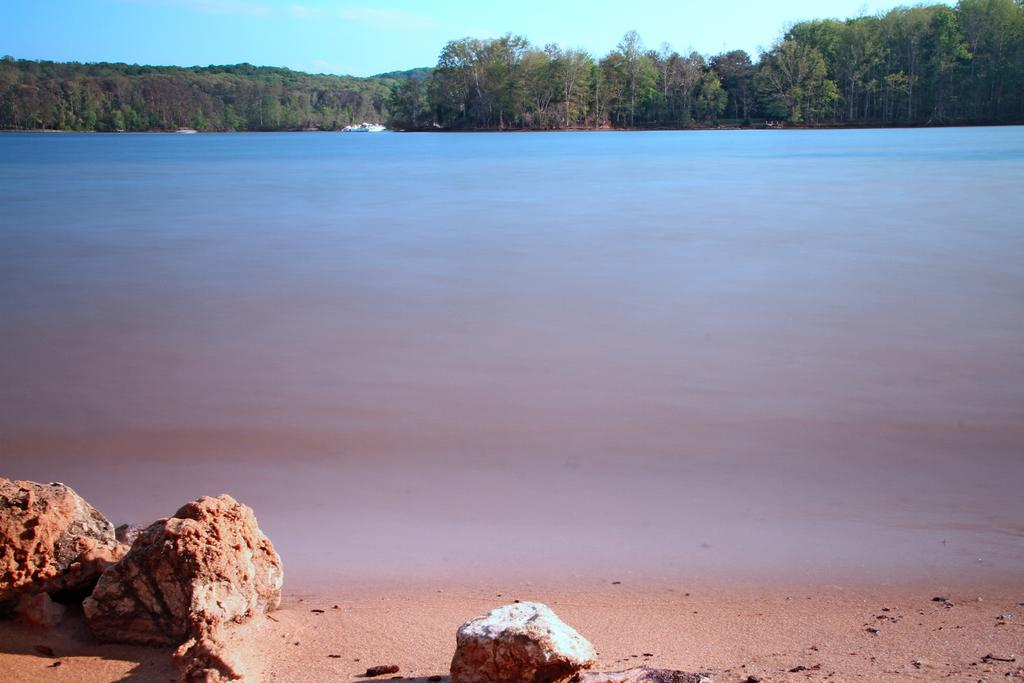What type of natural feature is present in the image? There is a river in the image. What can be seen on the left side of the image? There are stones on the left side bottom of the image. What is visible in the background of the image? There are trees and the sky in the background of the image. Is there a volcano visible in the image? No, there is no volcano present in the image. What side of the river is the image taken from? The image does not specify which side of the river it is taken from. 